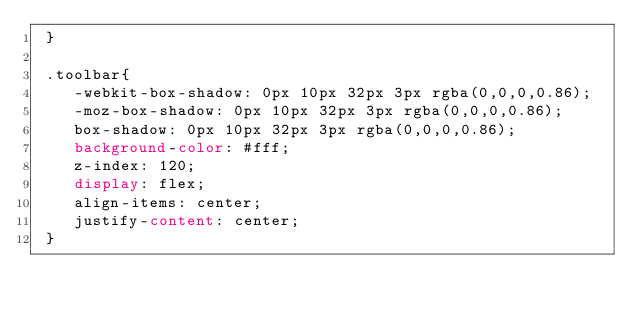Convert code to text. <code><loc_0><loc_0><loc_500><loc_500><_CSS_> }

 .toolbar{
    -webkit-box-shadow: 0px 10px 32px 3px rgba(0,0,0,0.86);
    -moz-box-shadow: 0px 10px 32px 3px rgba(0,0,0,0.86);
    box-shadow: 0px 10px 32px 3px rgba(0,0,0,0.86);
    background-color: #fff;
    z-index: 120;
    display: flex;
    align-items: center;
    justify-content: center;
 }</code> 